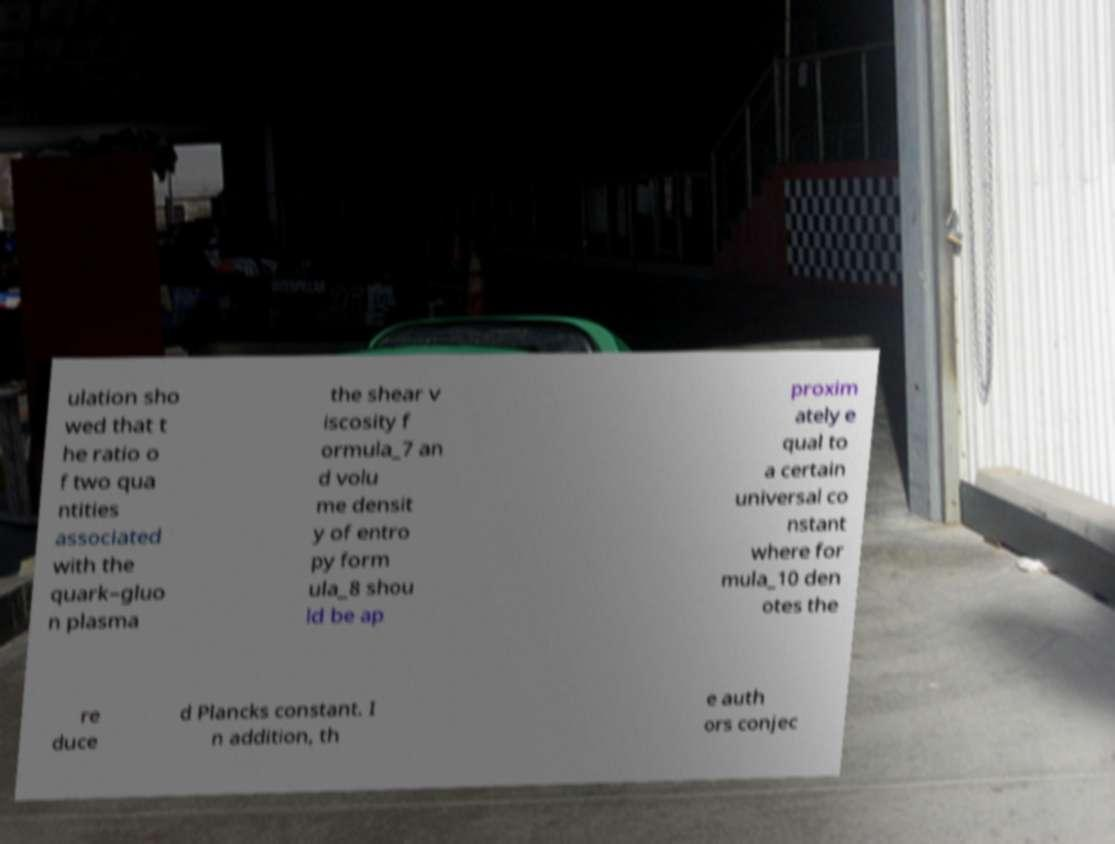Could you assist in decoding the text presented in this image and type it out clearly? ulation sho wed that t he ratio o f two qua ntities associated with the quark–gluo n plasma the shear v iscosity f ormula_7 an d volu me densit y of entro py form ula_8 shou ld be ap proxim ately e qual to a certain universal co nstant where for mula_10 den otes the re duce d Plancks constant. I n addition, th e auth ors conjec 